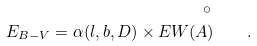<formula> <loc_0><loc_0><loc_500><loc_500>E _ { B - V } = \alpha ( l , b , D ) \times E W ( \AA ) \quad .</formula> 